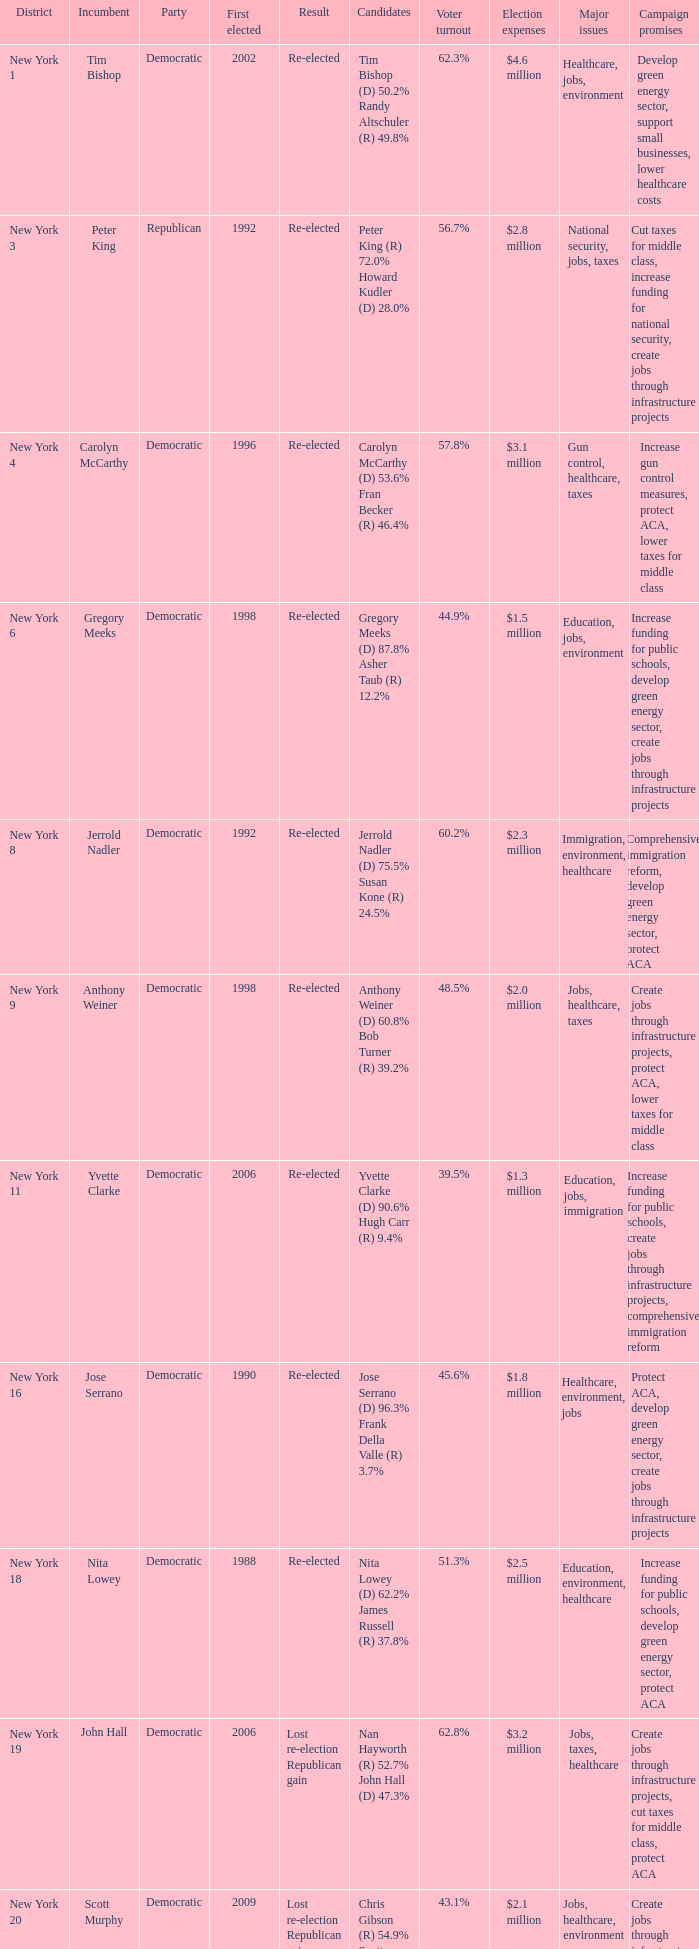Name the number of party for richard l. hanna (r) 53.1% mike arcuri (d) 46.9% 1.0. 